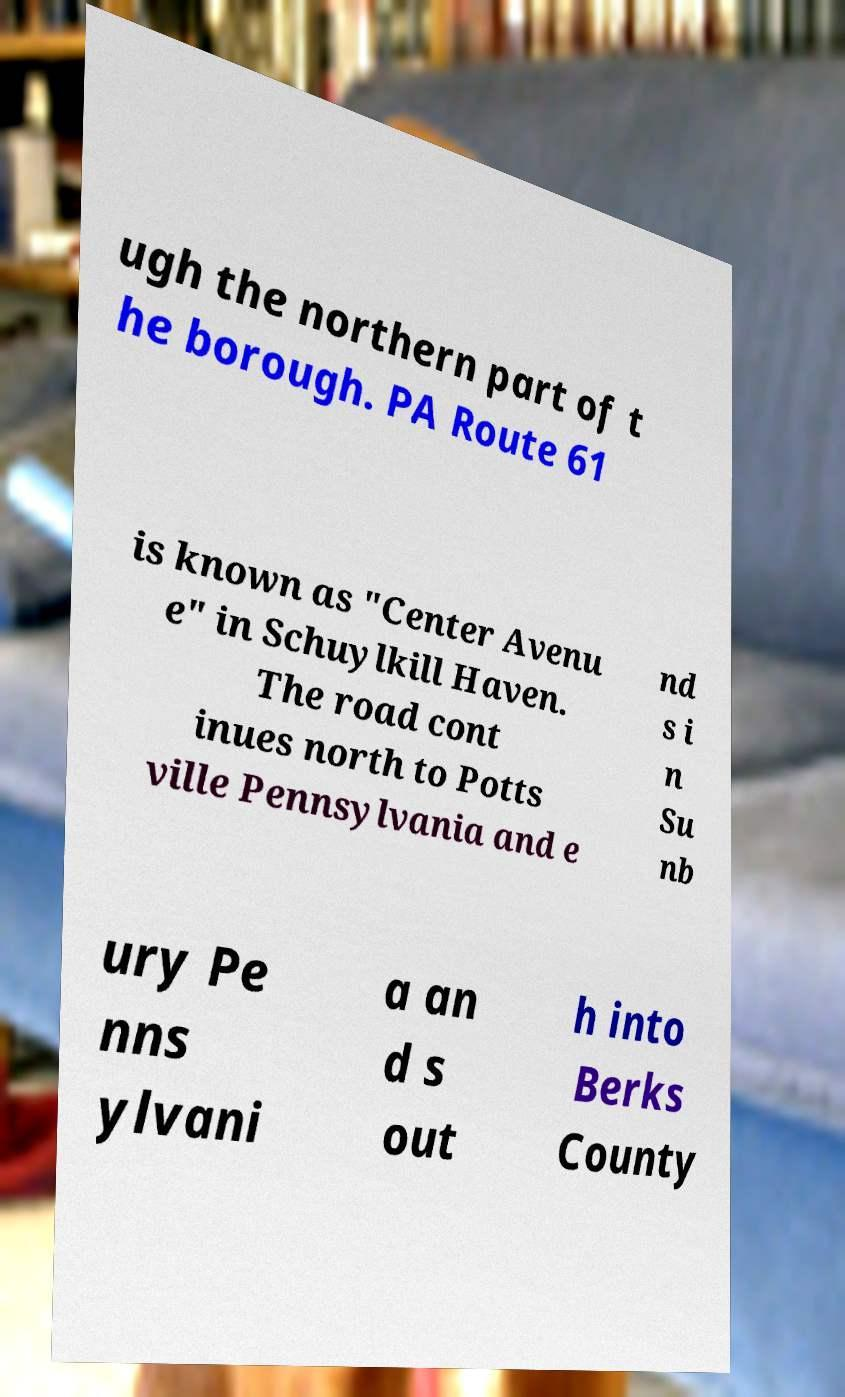Please read and relay the text visible in this image. What does it say? ugh the northern part of t he borough. PA Route 61 is known as "Center Avenu e" in Schuylkill Haven. The road cont inues north to Potts ville Pennsylvania and e nd s i n Su nb ury Pe nns ylvani a an d s out h into Berks County 